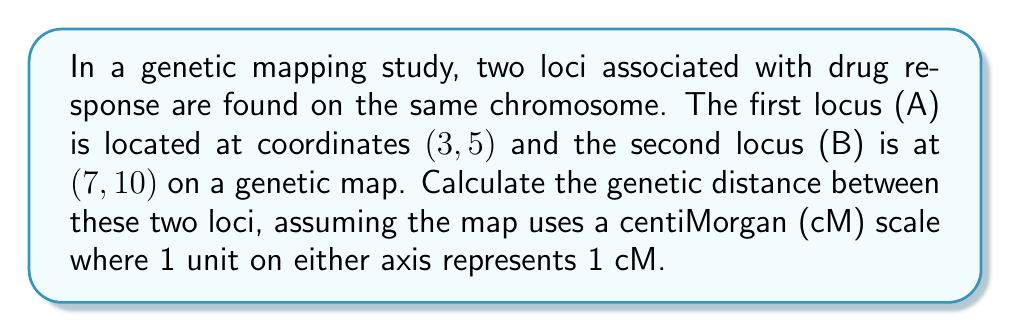Give your solution to this math problem. To calculate the genetic distance between two loci on a coordinate system, we can use the distance formula derived from the Pythagorean theorem:

$$ d = \sqrt{(x_2 - x_1)^2 + (y_2 - y_1)^2} $$

Where $(x_1, y_1)$ are the coordinates of the first point and $(x_2, y_2)$ are the coordinates of the second point.

Given:
- Locus A: $(x_1, y_1) = (3, 5)$
- Locus B: $(x_2, y_2) = (7, 10)$

Let's substitute these values into the formula:

$$ d = \sqrt{(7 - 3)^2 + (10 - 5)^2} $$

Simplify inside the parentheses:
$$ d = \sqrt{4^2 + 5^2} $$

Calculate the squares:
$$ d = \sqrt{16 + 25} $$

Add under the square root:
$$ d = \sqrt{41} $$

The square root of 41 is approximately 6.403 cM.

In genetics, distances are typically rounded to one decimal place, so we round 6.403 to 6.4 cM.
Answer: The genetic distance between the two loci is approximately 6.4 cM. 